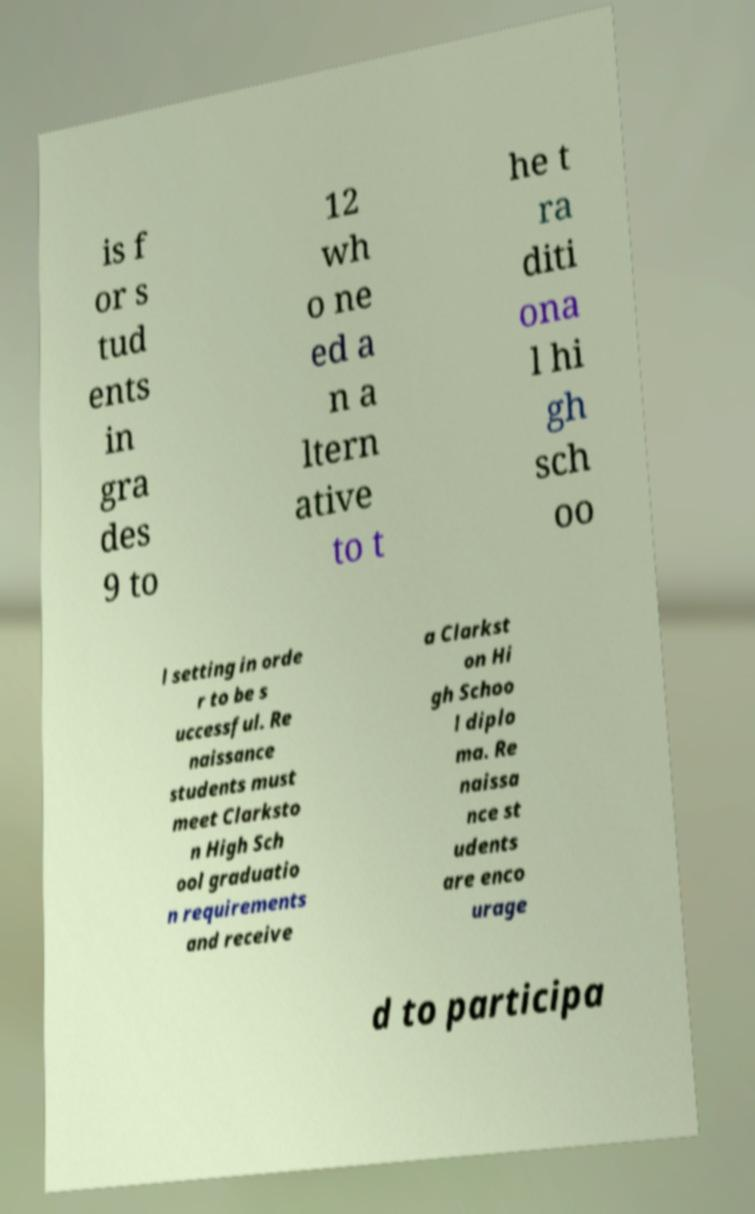Please read and relay the text visible in this image. What does it say? is f or s tud ents in gra des 9 to 12 wh o ne ed a n a ltern ative to t he t ra diti ona l hi gh sch oo l setting in orde r to be s uccessful. Re naissance students must meet Clarksto n High Sch ool graduatio n requirements and receive a Clarkst on Hi gh Schoo l diplo ma. Re naissa nce st udents are enco urage d to participa 